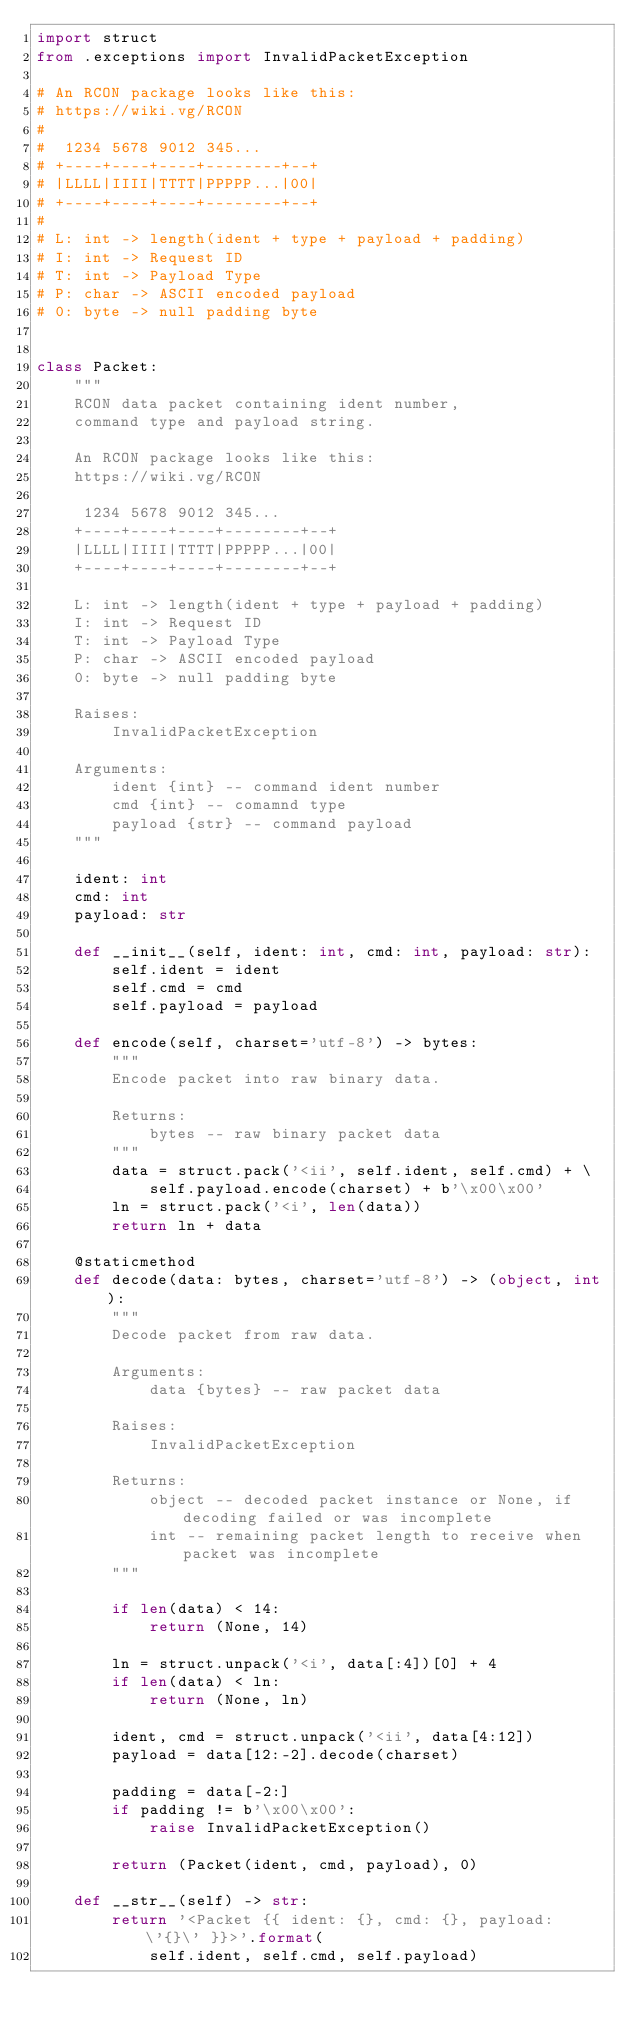<code> <loc_0><loc_0><loc_500><loc_500><_Python_>import struct
from .exceptions import InvalidPacketException

# An RCON package looks like this:
# https://wiki.vg/RCON
#
#  1234 5678 9012 345...
# +----+----+----+--------+--+
# |LLLL|IIII|TTTT|PPPPP...|00|
# +----+----+----+--------+--+
#
# L: int -> length(ident + type + payload + padding)
# I: int -> Request ID
# T: int -> Payload Type
# P: char -> ASCII encoded payload
# 0: byte -> null padding byte


class Packet:
    """
    RCON data packet containing ident number,
    command type and payload string.

    An RCON package looks like this:
    https://wiki.vg/RCON

     1234 5678 9012 345...
    +----+----+----+--------+--+
    |LLLL|IIII|TTTT|PPPPP...|00|
    +----+----+----+--------+--+

    L: int -> length(ident + type + payload + padding)
    I: int -> Request ID
    T: int -> Payload Type
    P: char -> ASCII encoded payload
    0: byte -> null padding byte

    Raises:
        InvalidPacketException

    Arguments:
        ident {int} -- command ident number
        cmd {int} -- comamnd type
        payload {str} -- command payload
    """

    ident: int
    cmd: int
    payload: str

    def __init__(self, ident: int, cmd: int, payload: str):
        self.ident = ident
        self.cmd = cmd
        self.payload = payload

    def encode(self, charset='utf-8') -> bytes:
        """
        Encode packet into raw binary data.

        Returns:
            bytes -- raw binary packet data
        """
        data = struct.pack('<ii', self.ident, self.cmd) + \
            self.payload.encode(charset) + b'\x00\x00'
        ln = struct.pack('<i', len(data))
        return ln + data

    @staticmethod
    def decode(data: bytes, charset='utf-8') -> (object, int):
        """
        Decode packet from raw data.

        Arguments:
            data {bytes} -- raw packet data

        Raises:
            InvalidPacketException

        Returns:
            object -- decoded packet instance or None, if decoding failed or was incomplete
            int -- remaining packet length to receive when packet was incomplete
        """

        if len(data) < 14:
            return (None, 14)

        ln = struct.unpack('<i', data[:4])[0] + 4
        if len(data) < ln:
            return (None, ln)

        ident, cmd = struct.unpack('<ii', data[4:12])
        payload = data[12:-2].decode(charset)

        padding = data[-2:]
        if padding != b'\x00\x00':
            raise InvalidPacketException()

        return (Packet(ident, cmd, payload), 0)

    def __str__(self) -> str:
        return '<Packet {{ ident: {}, cmd: {}, payload: \'{}\' }}>'.format(
            self.ident, self.cmd, self.payload)
</code> 